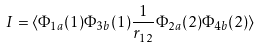<formula> <loc_0><loc_0><loc_500><loc_500>I = \langle \Phi _ { 1 a } ( 1 ) \Phi _ { 3 b } ( 1 ) \frac { 1 } { r _ { 1 2 } } \Phi _ { 2 a } ( 2 ) \Phi _ { 4 b } ( 2 ) \rangle</formula> 